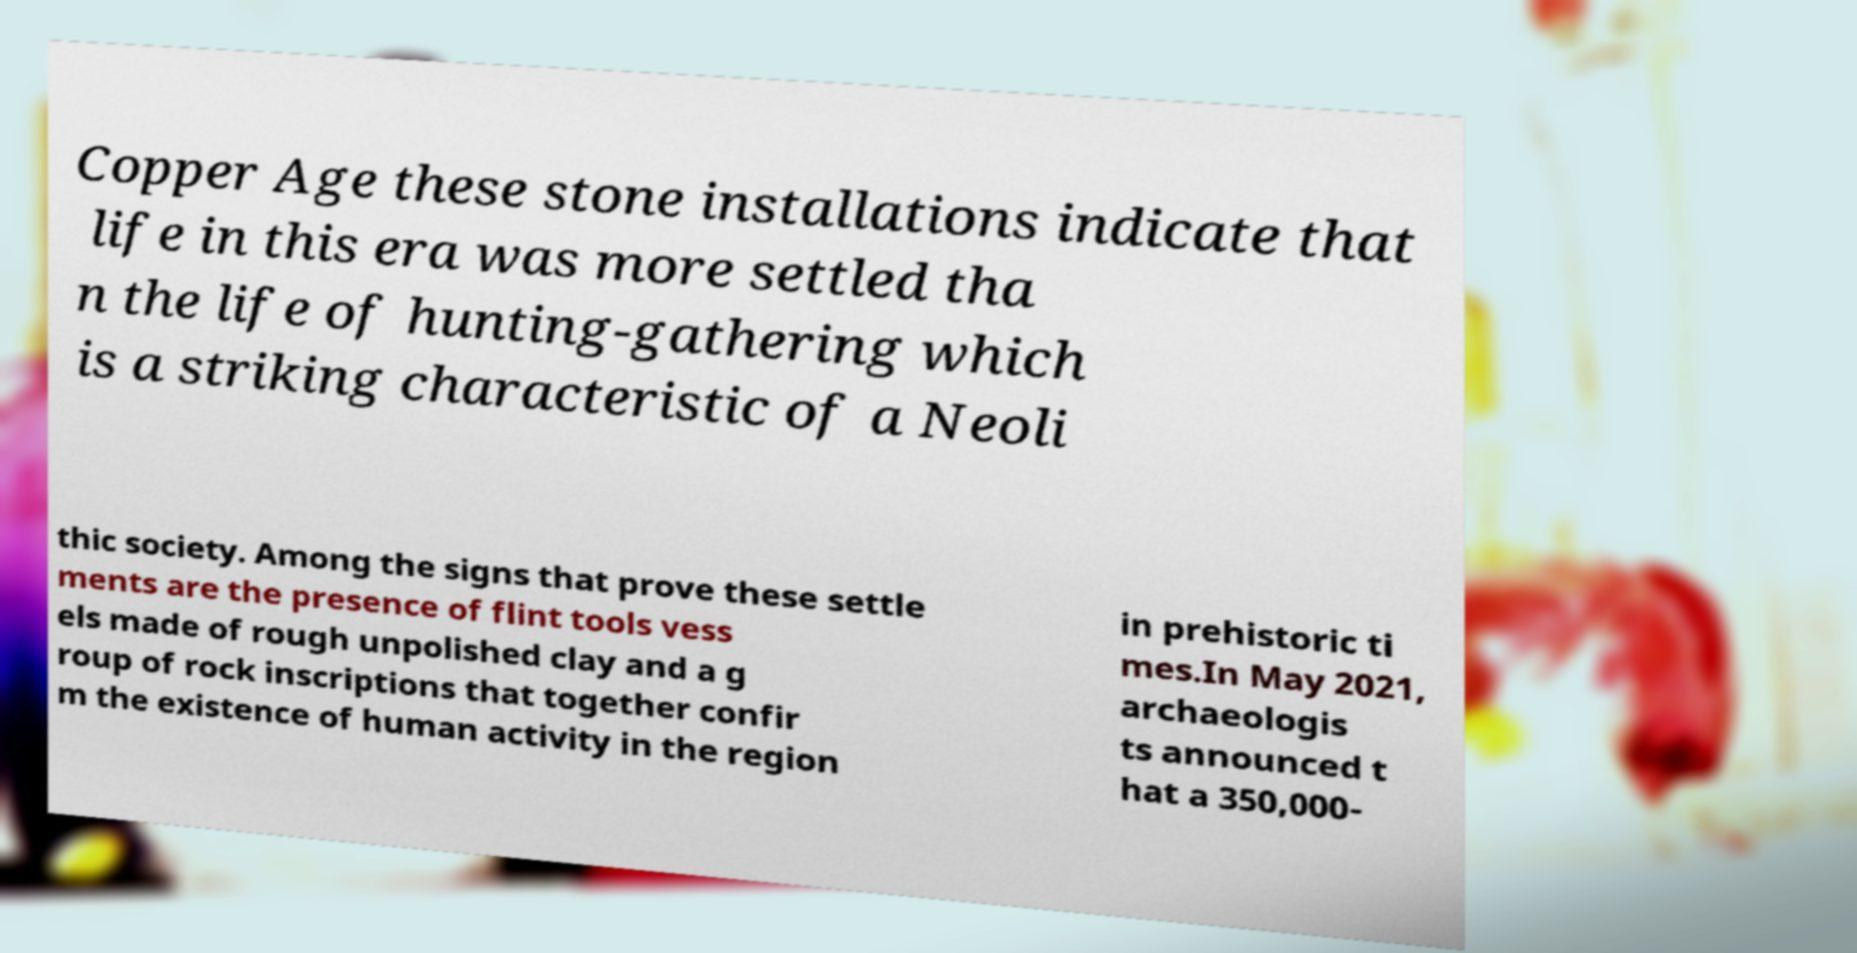For documentation purposes, I need the text within this image transcribed. Could you provide that? Copper Age these stone installations indicate that life in this era was more settled tha n the life of hunting-gathering which is a striking characteristic of a Neoli thic society. Among the signs that prove these settle ments are the presence of flint tools vess els made of rough unpolished clay and a g roup of rock inscriptions that together confir m the existence of human activity in the region in prehistoric ti mes.In May 2021, archaeologis ts announced t hat a 350,000- 